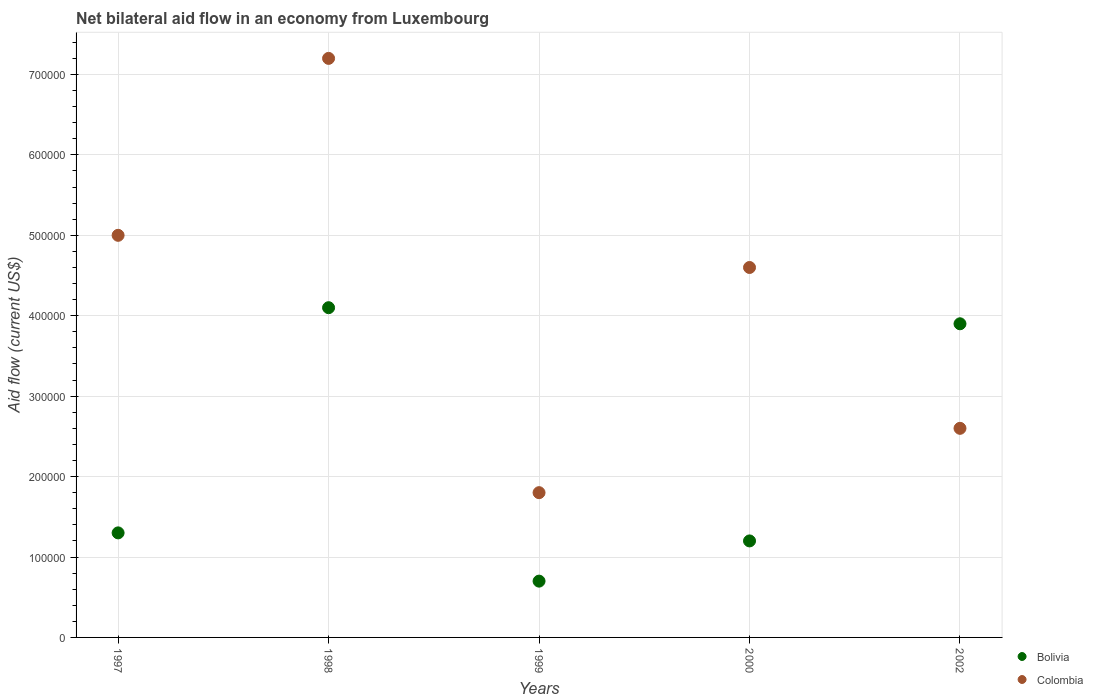How many different coloured dotlines are there?
Provide a succinct answer. 2. What is the net bilateral aid flow in Bolivia in 2002?
Offer a terse response. 3.90e+05. Across all years, what is the maximum net bilateral aid flow in Bolivia?
Your answer should be very brief. 4.10e+05. Across all years, what is the minimum net bilateral aid flow in Bolivia?
Offer a very short reply. 7.00e+04. In which year was the net bilateral aid flow in Colombia maximum?
Provide a succinct answer. 1998. What is the total net bilateral aid flow in Bolivia in the graph?
Your answer should be compact. 1.12e+06. What is the difference between the net bilateral aid flow in Bolivia in 1997 and that in 1999?
Provide a succinct answer. 6.00e+04. What is the average net bilateral aid flow in Bolivia per year?
Your response must be concise. 2.24e+05. What is the ratio of the net bilateral aid flow in Bolivia in 2000 to that in 2002?
Offer a terse response. 0.31. Is the net bilateral aid flow in Colombia in 2000 less than that in 2002?
Offer a terse response. No. What is the difference between the highest and the lowest net bilateral aid flow in Bolivia?
Your response must be concise. 3.40e+05. Does the net bilateral aid flow in Colombia monotonically increase over the years?
Keep it short and to the point. No. Is the net bilateral aid flow in Bolivia strictly less than the net bilateral aid flow in Colombia over the years?
Make the answer very short. No. How many years are there in the graph?
Ensure brevity in your answer.  5. Are the values on the major ticks of Y-axis written in scientific E-notation?
Your response must be concise. No. Does the graph contain any zero values?
Your answer should be compact. No. Where does the legend appear in the graph?
Make the answer very short. Bottom right. What is the title of the graph?
Keep it short and to the point. Net bilateral aid flow in an economy from Luxembourg. Does "Qatar" appear as one of the legend labels in the graph?
Offer a terse response. No. What is the label or title of the X-axis?
Provide a succinct answer. Years. What is the label or title of the Y-axis?
Offer a very short reply. Aid flow (current US$). What is the Aid flow (current US$) of Colombia in 1997?
Make the answer very short. 5.00e+05. What is the Aid flow (current US$) of Bolivia in 1998?
Offer a very short reply. 4.10e+05. What is the Aid flow (current US$) of Colombia in 1998?
Make the answer very short. 7.20e+05. What is the Aid flow (current US$) in Bolivia in 1999?
Offer a very short reply. 7.00e+04. What is the Aid flow (current US$) of Colombia in 2002?
Provide a succinct answer. 2.60e+05. Across all years, what is the maximum Aid flow (current US$) in Colombia?
Your answer should be compact. 7.20e+05. Across all years, what is the minimum Aid flow (current US$) in Bolivia?
Ensure brevity in your answer.  7.00e+04. Across all years, what is the minimum Aid flow (current US$) in Colombia?
Offer a very short reply. 1.80e+05. What is the total Aid flow (current US$) of Bolivia in the graph?
Your answer should be very brief. 1.12e+06. What is the total Aid flow (current US$) of Colombia in the graph?
Your response must be concise. 2.12e+06. What is the difference between the Aid flow (current US$) of Bolivia in 1997 and that in 1998?
Give a very brief answer. -2.80e+05. What is the difference between the Aid flow (current US$) of Bolivia in 1997 and that in 1999?
Offer a very short reply. 6.00e+04. What is the difference between the Aid flow (current US$) of Colombia in 1997 and that in 1999?
Offer a very short reply. 3.20e+05. What is the difference between the Aid flow (current US$) in Bolivia in 1997 and that in 2002?
Your response must be concise. -2.60e+05. What is the difference between the Aid flow (current US$) of Colombia in 1997 and that in 2002?
Your response must be concise. 2.40e+05. What is the difference between the Aid flow (current US$) of Bolivia in 1998 and that in 1999?
Offer a terse response. 3.40e+05. What is the difference between the Aid flow (current US$) of Colombia in 1998 and that in 1999?
Your response must be concise. 5.40e+05. What is the difference between the Aid flow (current US$) of Colombia in 1998 and that in 2000?
Your response must be concise. 2.60e+05. What is the difference between the Aid flow (current US$) in Bolivia in 1998 and that in 2002?
Your answer should be very brief. 2.00e+04. What is the difference between the Aid flow (current US$) of Colombia in 1998 and that in 2002?
Offer a terse response. 4.60e+05. What is the difference between the Aid flow (current US$) of Colombia in 1999 and that in 2000?
Provide a succinct answer. -2.80e+05. What is the difference between the Aid flow (current US$) of Bolivia in 1999 and that in 2002?
Offer a terse response. -3.20e+05. What is the difference between the Aid flow (current US$) of Colombia in 1999 and that in 2002?
Make the answer very short. -8.00e+04. What is the difference between the Aid flow (current US$) in Bolivia in 2000 and that in 2002?
Your response must be concise. -2.70e+05. What is the difference between the Aid flow (current US$) in Bolivia in 1997 and the Aid flow (current US$) in Colombia in 1998?
Offer a very short reply. -5.90e+05. What is the difference between the Aid flow (current US$) of Bolivia in 1997 and the Aid flow (current US$) of Colombia in 1999?
Keep it short and to the point. -5.00e+04. What is the difference between the Aid flow (current US$) in Bolivia in 1997 and the Aid flow (current US$) in Colombia in 2000?
Your answer should be compact. -3.30e+05. What is the difference between the Aid flow (current US$) in Bolivia in 1997 and the Aid flow (current US$) in Colombia in 2002?
Your answer should be very brief. -1.30e+05. What is the difference between the Aid flow (current US$) in Bolivia in 1998 and the Aid flow (current US$) in Colombia in 2000?
Your response must be concise. -5.00e+04. What is the difference between the Aid flow (current US$) of Bolivia in 1999 and the Aid flow (current US$) of Colombia in 2000?
Your answer should be very brief. -3.90e+05. What is the average Aid flow (current US$) of Bolivia per year?
Your answer should be very brief. 2.24e+05. What is the average Aid flow (current US$) in Colombia per year?
Ensure brevity in your answer.  4.24e+05. In the year 1997, what is the difference between the Aid flow (current US$) of Bolivia and Aid flow (current US$) of Colombia?
Offer a terse response. -3.70e+05. In the year 1998, what is the difference between the Aid flow (current US$) of Bolivia and Aid flow (current US$) of Colombia?
Make the answer very short. -3.10e+05. In the year 2002, what is the difference between the Aid flow (current US$) of Bolivia and Aid flow (current US$) of Colombia?
Provide a succinct answer. 1.30e+05. What is the ratio of the Aid flow (current US$) of Bolivia in 1997 to that in 1998?
Keep it short and to the point. 0.32. What is the ratio of the Aid flow (current US$) in Colombia in 1997 to that in 1998?
Your answer should be very brief. 0.69. What is the ratio of the Aid flow (current US$) in Bolivia in 1997 to that in 1999?
Give a very brief answer. 1.86. What is the ratio of the Aid flow (current US$) in Colombia in 1997 to that in 1999?
Provide a succinct answer. 2.78. What is the ratio of the Aid flow (current US$) in Colombia in 1997 to that in 2000?
Your answer should be very brief. 1.09. What is the ratio of the Aid flow (current US$) in Colombia in 1997 to that in 2002?
Provide a succinct answer. 1.92. What is the ratio of the Aid flow (current US$) in Bolivia in 1998 to that in 1999?
Give a very brief answer. 5.86. What is the ratio of the Aid flow (current US$) of Bolivia in 1998 to that in 2000?
Offer a very short reply. 3.42. What is the ratio of the Aid flow (current US$) in Colombia in 1998 to that in 2000?
Keep it short and to the point. 1.57. What is the ratio of the Aid flow (current US$) of Bolivia in 1998 to that in 2002?
Keep it short and to the point. 1.05. What is the ratio of the Aid flow (current US$) in Colombia in 1998 to that in 2002?
Your response must be concise. 2.77. What is the ratio of the Aid flow (current US$) of Bolivia in 1999 to that in 2000?
Your response must be concise. 0.58. What is the ratio of the Aid flow (current US$) in Colombia in 1999 to that in 2000?
Keep it short and to the point. 0.39. What is the ratio of the Aid flow (current US$) of Bolivia in 1999 to that in 2002?
Your response must be concise. 0.18. What is the ratio of the Aid flow (current US$) of Colombia in 1999 to that in 2002?
Offer a very short reply. 0.69. What is the ratio of the Aid flow (current US$) in Bolivia in 2000 to that in 2002?
Provide a short and direct response. 0.31. What is the ratio of the Aid flow (current US$) of Colombia in 2000 to that in 2002?
Your response must be concise. 1.77. What is the difference between the highest and the second highest Aid flow (current US$) in Colombia?
Ensure brevity in your answer.  2.20e+05. What is the difference between the highest and the lowest Aid flow (current US$) of Bolivia?
Provide a short and direct response. 3.40e+05. What is the difference between the highest and the lowest Aid flow (current US$) in Colombia?
Offer a terse response. 5.40e+05. 